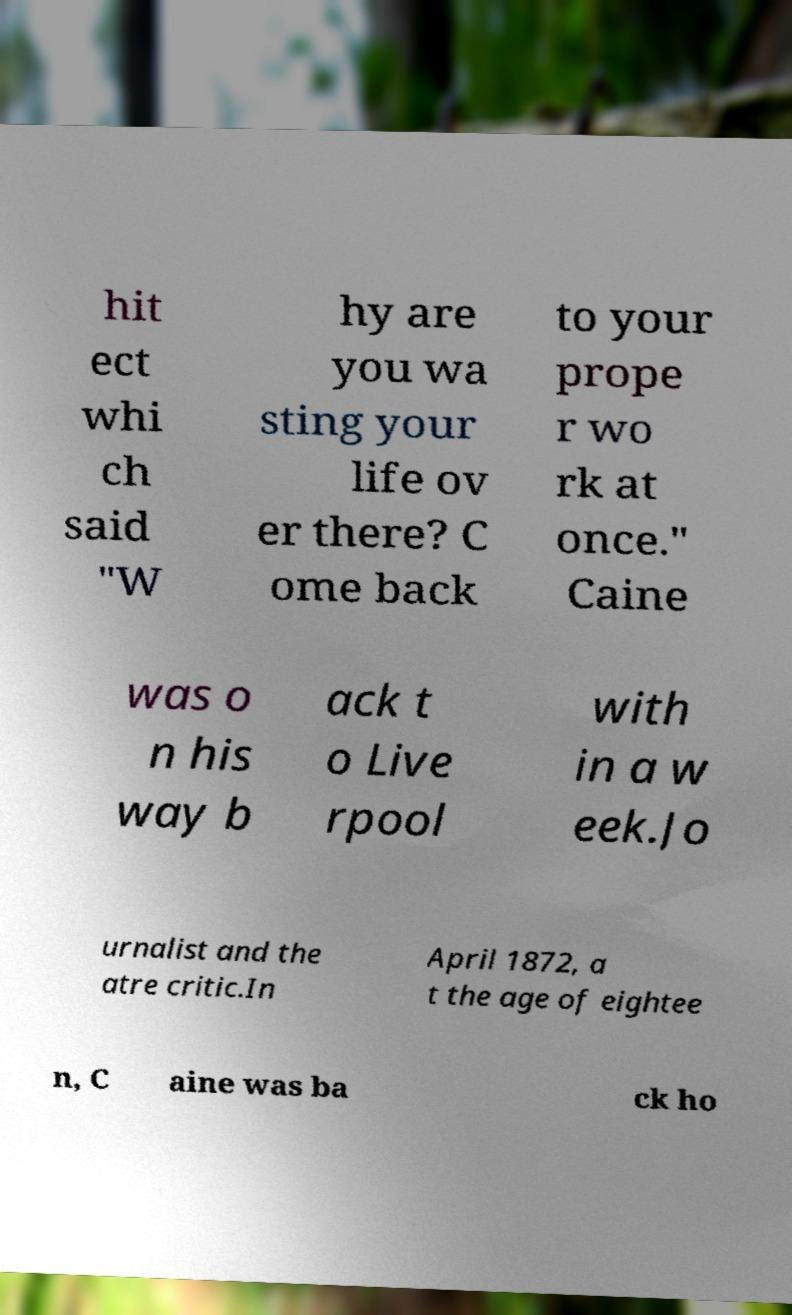Could you assist in decoding the text presented in this image and type it out clearly? hit ect whi ch said "W hy are you wa sting your life ov er there? C ome back to your prope r wo rk at once." Caine was o n his way b ack t o Live rpool with in a w eek.Jo urnalist and the atre critic.In April 1872, a t the age of eightee n, C aine was ba ck ho 